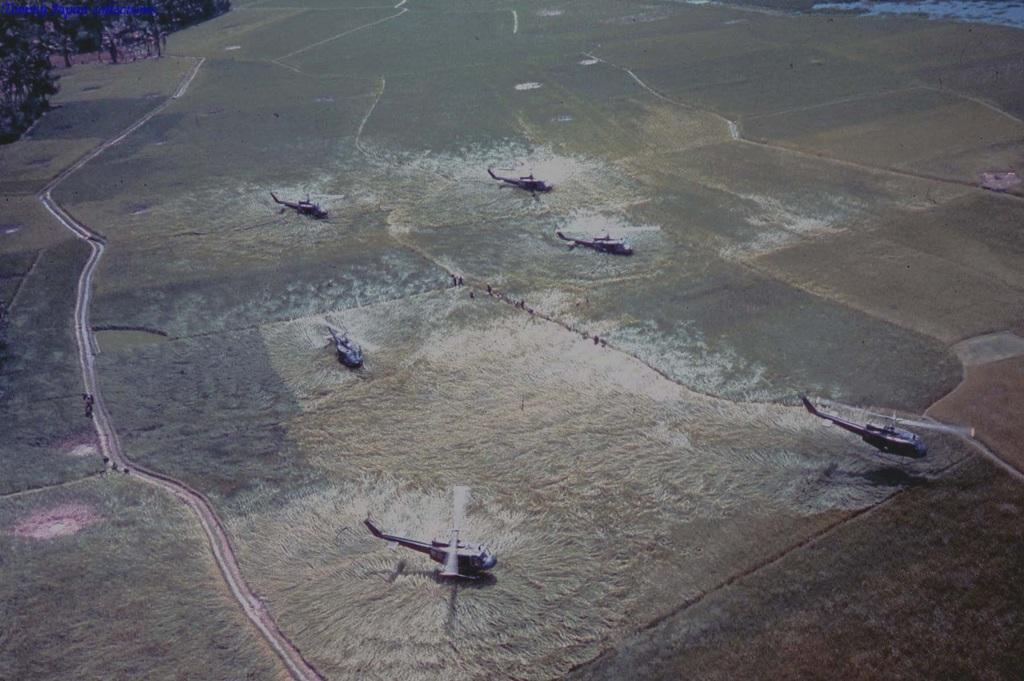What type of vehicles are present in the image? There are helicopters in the image. What can be seen in the top left corner of the image? There are trees in the top left of the image. What is the texture of the quiet step in the image? There is no mention of a quiet step or any texture in the image; it features helicopters and trees. 